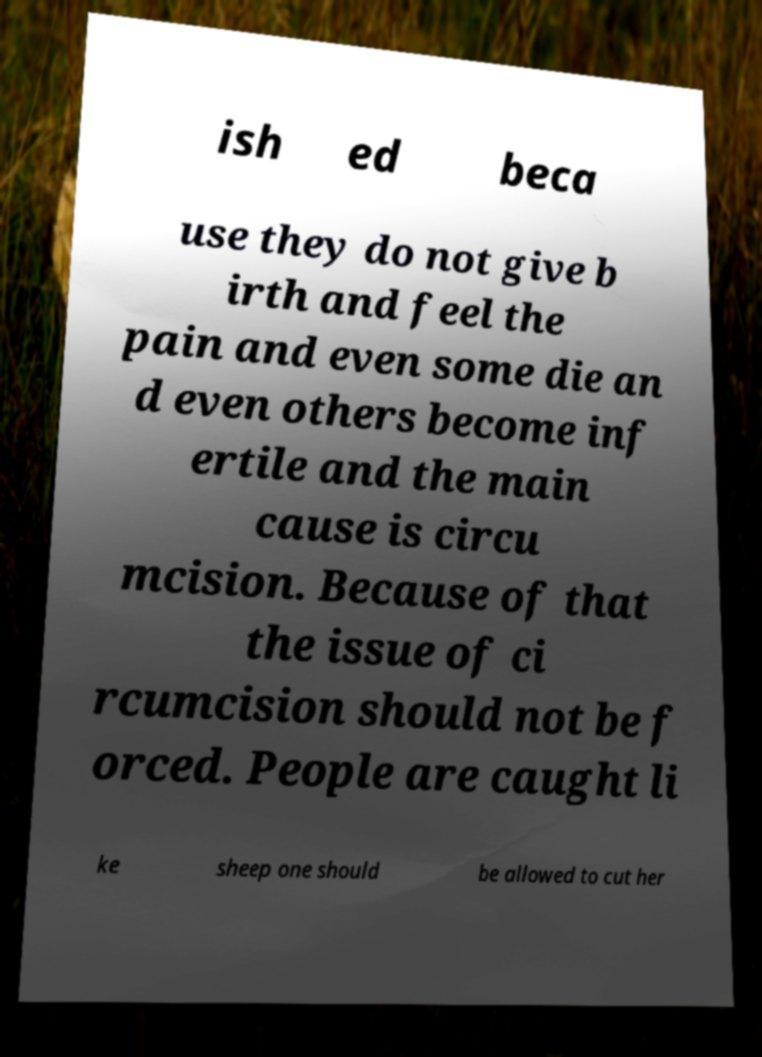Please read and relay the text visible in this image. What does it say? ish ed beca use they do not give b irth and feel the pain and even some die an d even others become inf ertile and the main cause is circu mcision. Because of that the issue of ci rcumcision should not be f orced. People are caught li ke sheep one should be allowed to cut her 